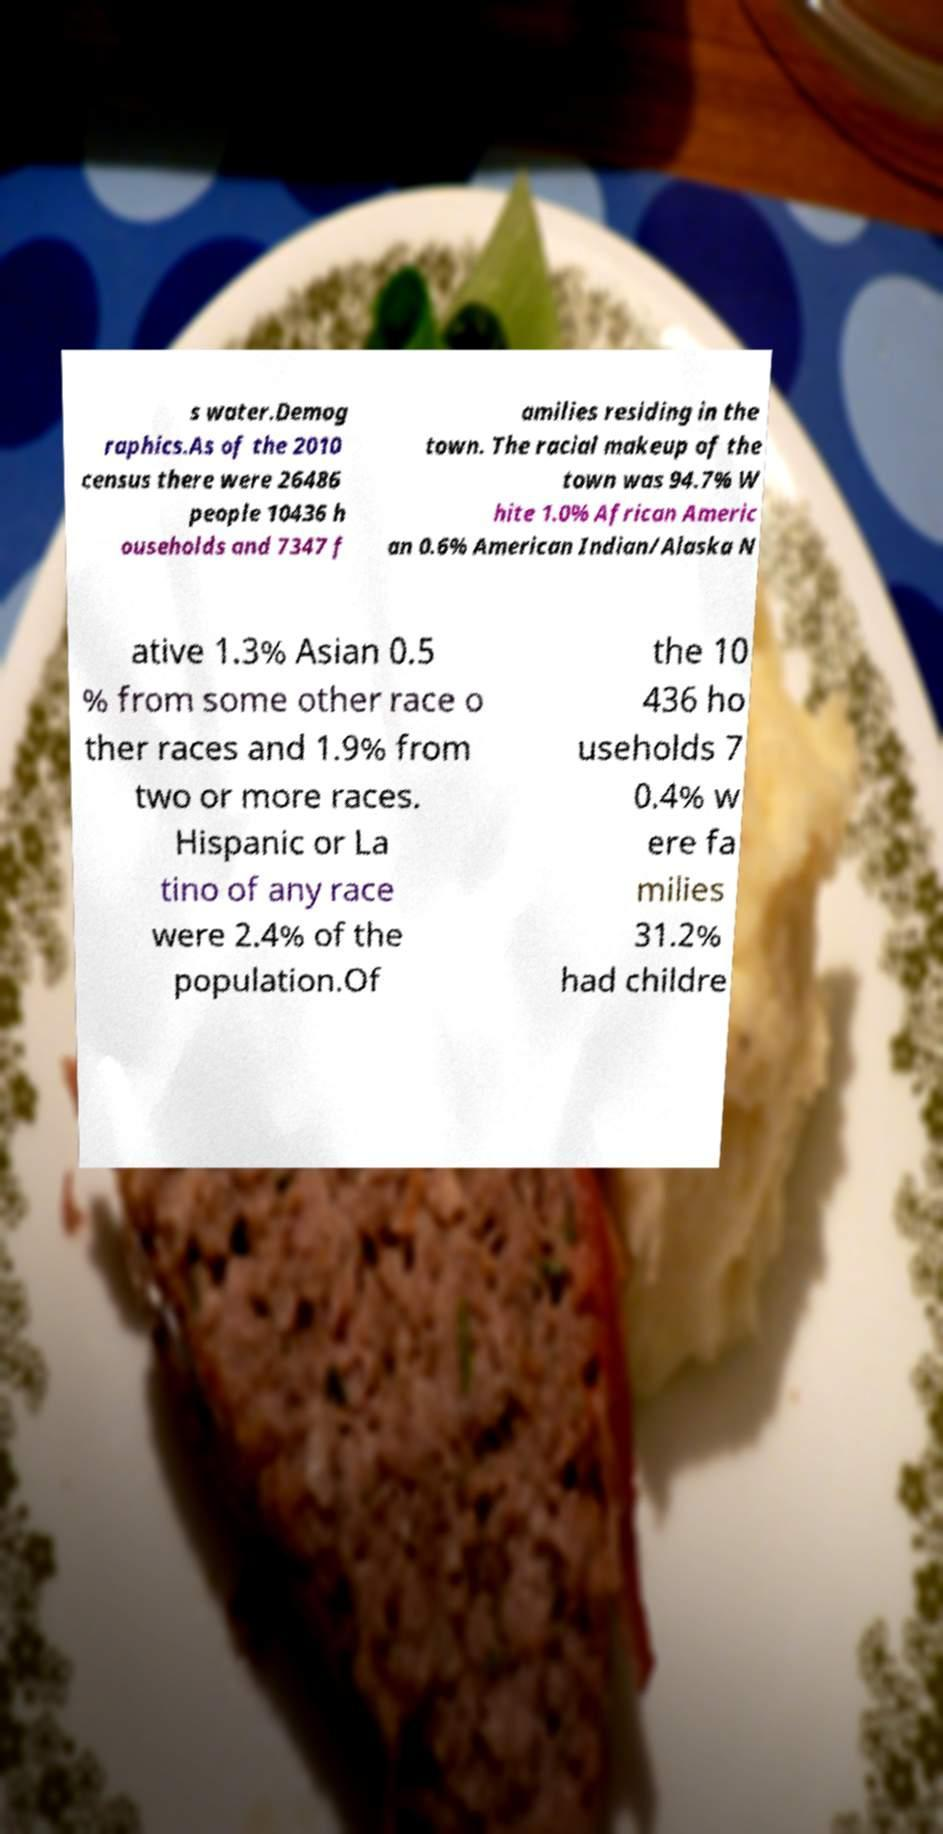Can you accurately transcribe the text from the provided image for me? s water.Demog raphics.As of the 2010 census there were 26486 people 10436 h ouseholds and 7347 f amilies residing in the town. The racial makeup of the town was 94.7% W hite 1.0% African Americ an 0.6% American Indian/Alaska N ative 1.3% Asian 0.5 % from some other race o ther races and 1.9% from two or more races. Hispanic or La tino of any race were 2.4% of the population.Of the 10 436 ho useholds 7 0.4% w ere fa milies 31.2% had childre 